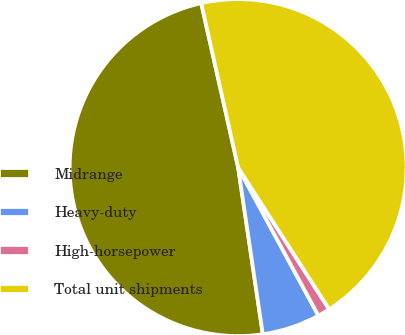<chart> <loc_0><loc_0><loc_500><loc_500><pie_chart><fcel>Midrange<fcel>Heavy-duty<fcel>High-horsepower<fcel>Total unit shipments<nl><fcel>48.82%<fcel>5.57%<fcel>1.18%<fcel>44.43%<nl></chart> 